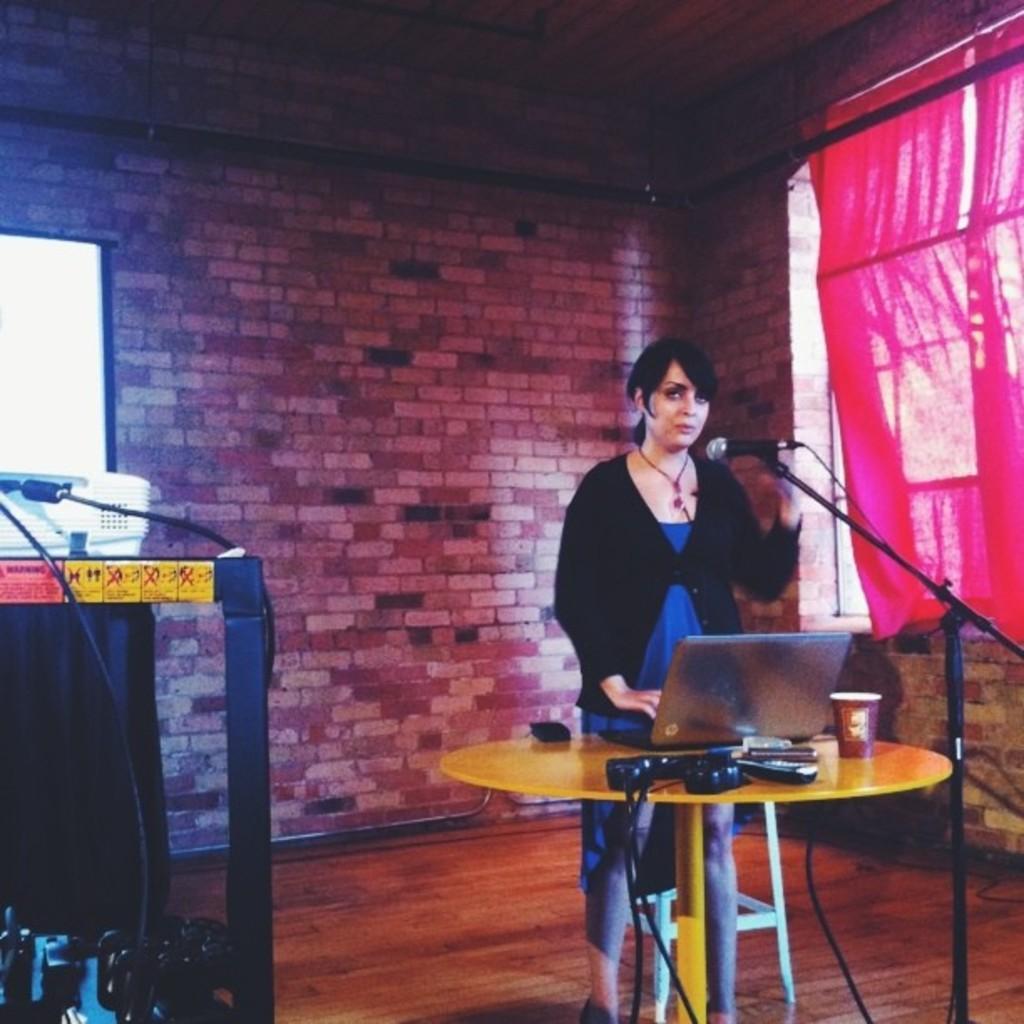In one or two sentences, can you explain what this image depicts? In this picture there is a lady who is standing on the right side of the image, in front of a table and there is a laptop, glass, and remotes on the table and there is an electric box, with wires and a projector screen on the left side of the image, there is a window on the right side of the image. 